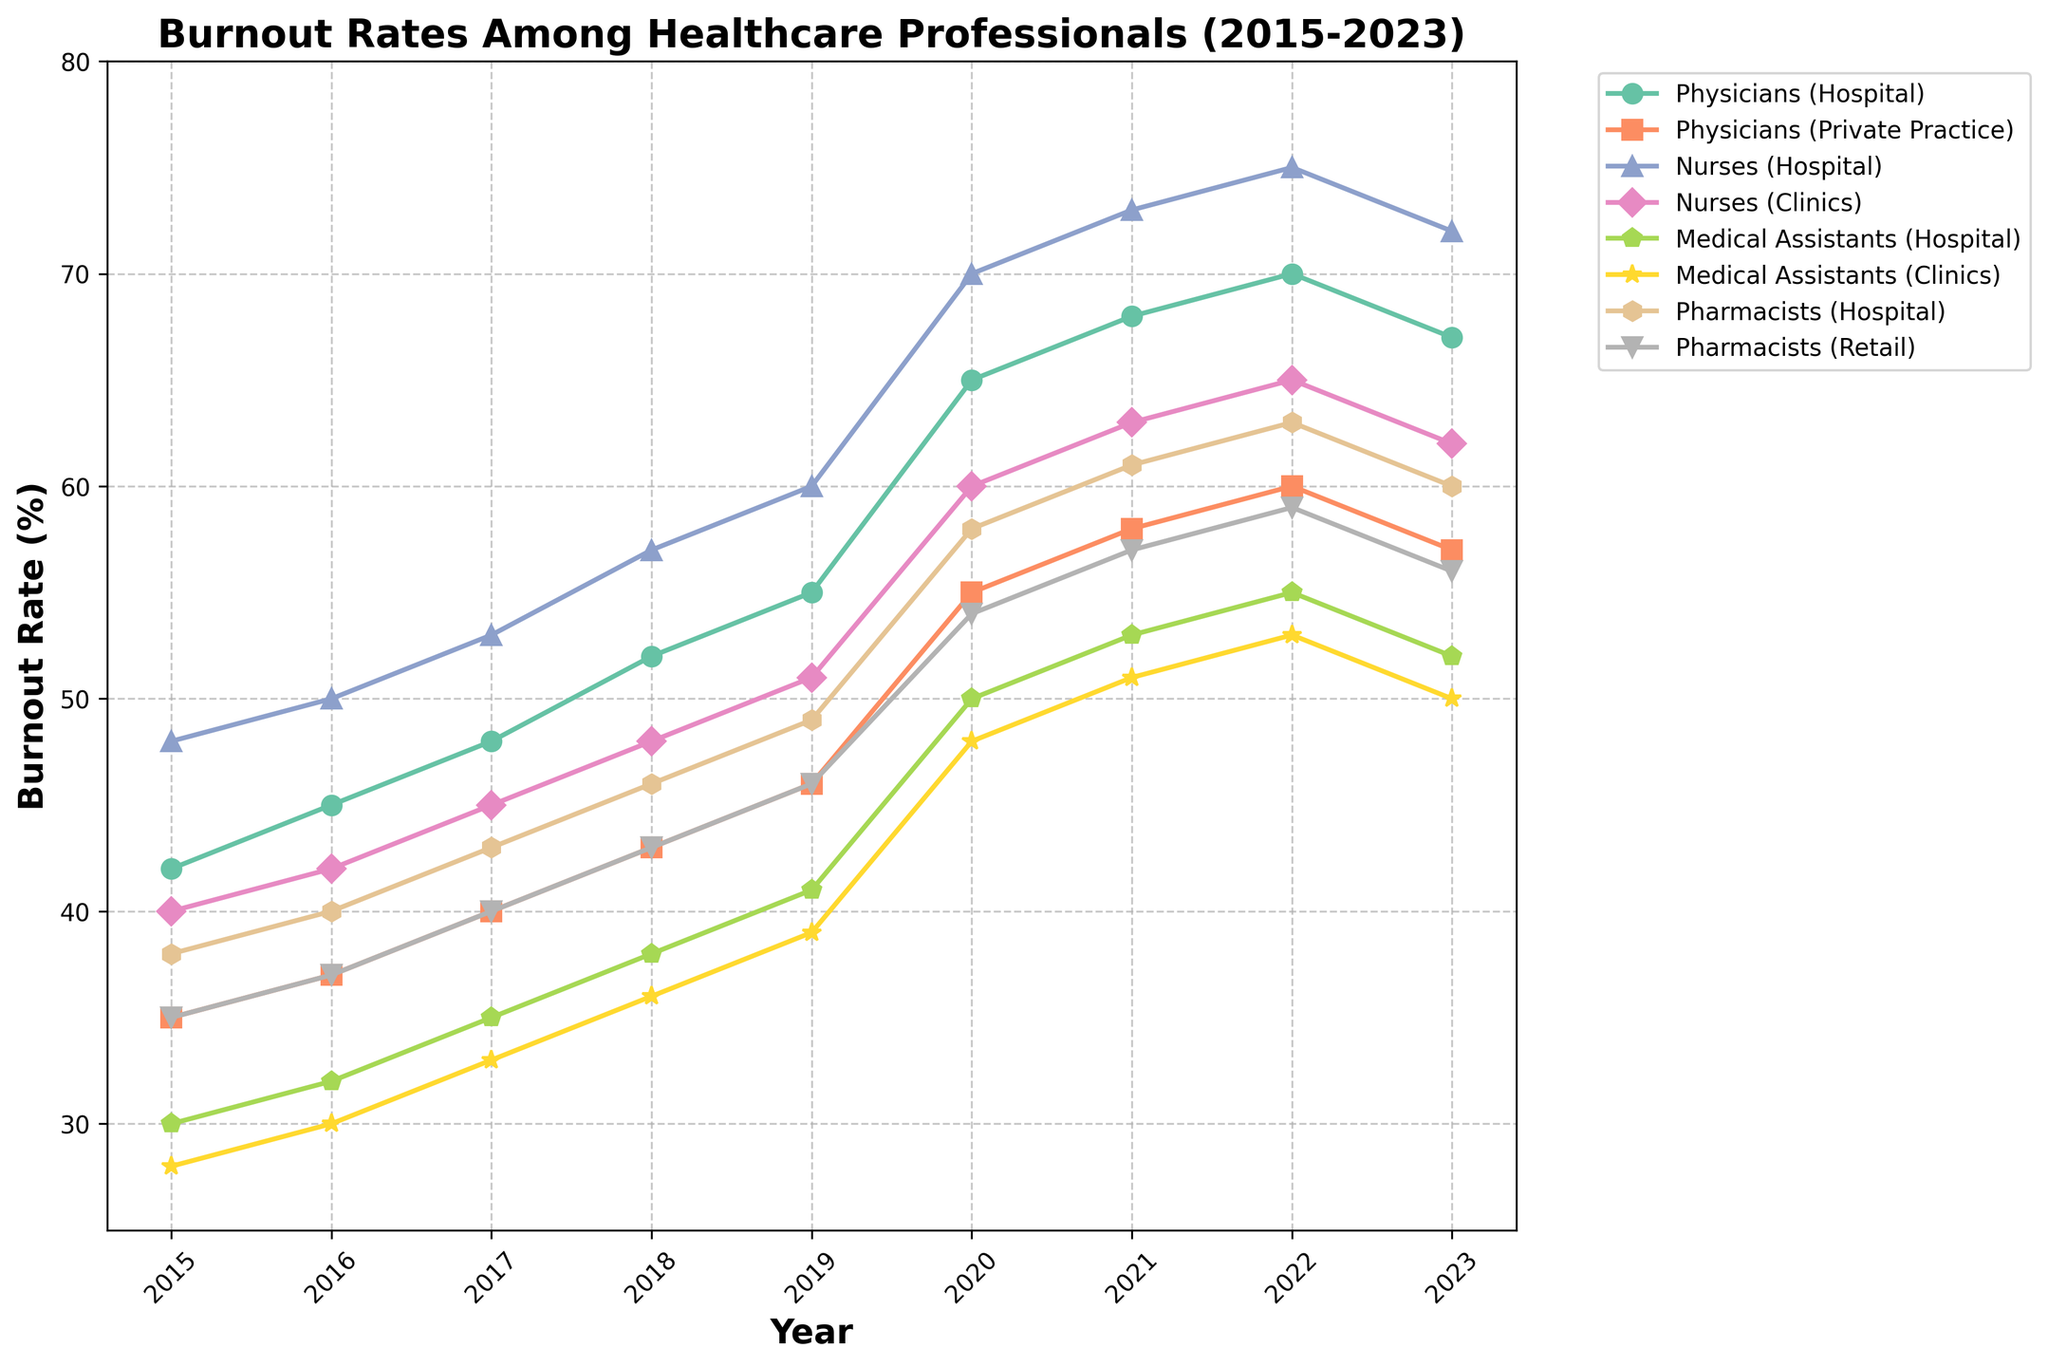What's the trend in burnout rates for Physicians in Hospitals from 2015 to 2023? Observe the line corresponding to Physicians in Hospitals, which steadily increases from 42% in 2015 to a peak of 70% in 2022 before slightly decreasing to 67% in 2023.
Answer: It increases, peaks in 2022, then slightly decreases Which role experienced the highest burnout rate in 2023? Compare the data points for each role in 2023. Nurses in Hospitals have the highest burnout rate at 72%.
Answer: Nurses in Hospitals What was the difference in burnout rates between Medical Assistants in Clinics and Pharmacists in Retail in 2020? Look at the data points for both roles in 2020: Medical Assistants in Clinics at 48% and Pharmacists in Retail at 54%. Calculate the difference: 54% - 48% = 6%.
Answer: 6% Which roles had a burnout rate of over 50% in 2021? Identify roles with data points above 50% in 2021. These include Physicians in Hospitals, Nurses in Hospitals, Nurses in Clinics, Medical Assistants in Hospitals, Pharmacists in Hospitals, and Pharmacists in Retail.
Answer: Physicians in Hospitals, Nurses in Hospitals, Nurses in Clinics, Medical Assistants in Hospitals, Pharmacists in Hospitals, Pharmacists in Retail What was the overall trend in burnout rates for Nurses in Clinics from 2015 to 2023? Follow the line for Nurses in Clinics, starting at 40% in 2015 and continuously increasing to 65% by 2022 before decreasing to 62% in 2023.
Answer: Continuous increase with a slight decrease in 2023 By how much did the burnout rate for Medical Assistants in Hospitals change from 2019 to 2023? Note the values for Medical Assistants in Hospitals in 2019 (41%) and 2023 (52%). Calculate the change: 52% - 41% = 11%.
Answer: 11% Which role experienced the steepest increase in burnout rates between 2019 and 2020? Compare the slopes of each line from 2019 to 2020. Nurses in Hospitals have the steepest increase from 60% to 70%, a change of 10%.
Answer: Nurses in Hospitals What is the average burnout rate for Pharmacists in Hospitals between 2015 and 2023? Sum the burnout rates for Pharmacists in Hospitals over these years and divide by the number of years: (38 + 40 + 43 + 46 + 49 + 58 + 61 + 63 + 60) / 9 = 50.89%.
Answer: 50.89% Which two roles had the smallest difference in burnout rates in 2023? Compare the 2023 burnout rates to find the two closest values: Physicians in Private Practice (57%) and Pharmacists in Retail (56%) have a difference of 1%.
Answer: Physicians in Private Practice and Pharmacists in Retail What was the burnout rate trend for Medical Assistants in Clinics from 2015 to 2023? Observe the line for Medical Assistants in Clinics. The trend shows a steady increase from 28% in 2015 to 53% in 2022, then a decrease to 50% in 2023.
Answer: Steady increase, peaking in 2022, then slight decrease What's the difference in burnout rate between the highest and lowest roles in 2021? Identify the highest rate in 2021: Nurses in Hospitals (73%) and the lowest: Medical Assistants in Clinics (51%). Calculate the difference: 73% - 51% = 22%.
Answer: 22% 